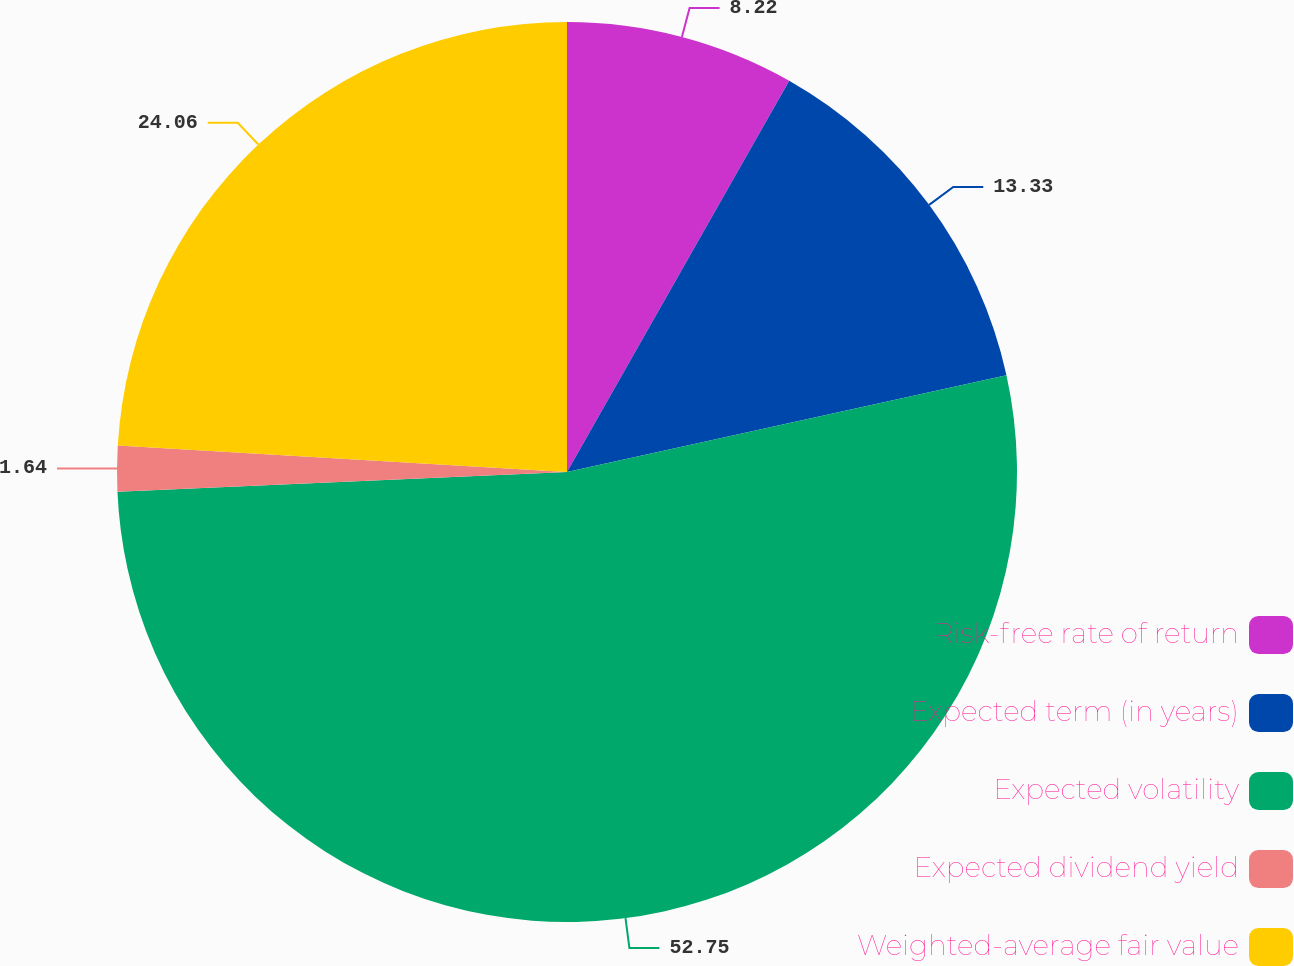Convert chart to OTSL. <chart><loc_0><loc_0><loc_500><loc_500><pie_chart><fcel>Risk-free rate of return<fcel>Expected term (in years)<fcel>Expected volatility<fcel>Expected dividend yield<fcel>Weighted-average fair value<nl><fcel>8.22%<fcel>13.33%<fcel>52.75%<fcel>1.64%<fcel>24.06%<nl></chart> 